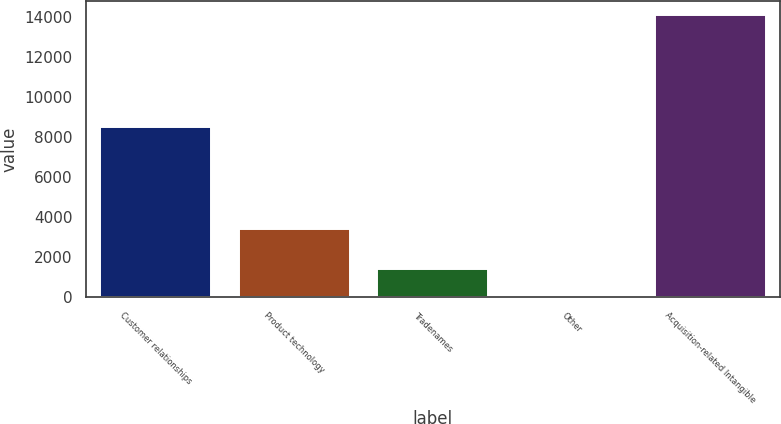<chart> <loc_0><loc_0><loc_500><loc_500><bar_chart><fcel>Customer relationships<fcel>Product technology<fcel>Tradenames<fcel>Other<fcel>Acquisition-related Intangible<nl><fcel>8526.2<fcel>3396.8<fcel>1411.82<fcel>0.9<fcel>14110.1<nl></chart> 